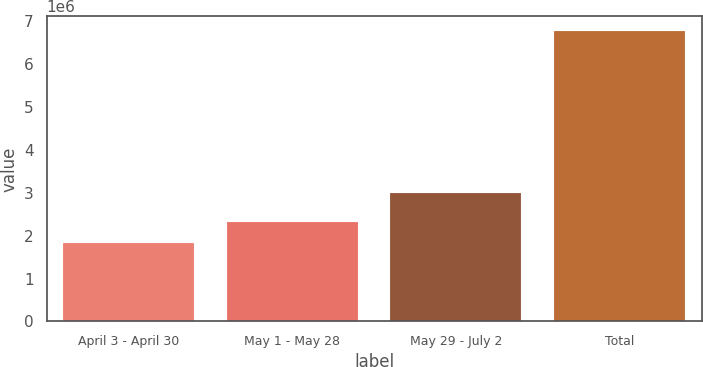Convert chart. <chart><loc_0><loc_0><loc_500><loc_500><bar_chart><fcel>April 3 - April 30<fcel>May 1 - May 28<fcel>May 29 - July 2<fcel>Total<nl><fcel>1.82282e+06<fcel>2.31805e+06<fcel>3.00082e+06<fcel>6.77513e+06<nl></chart> 